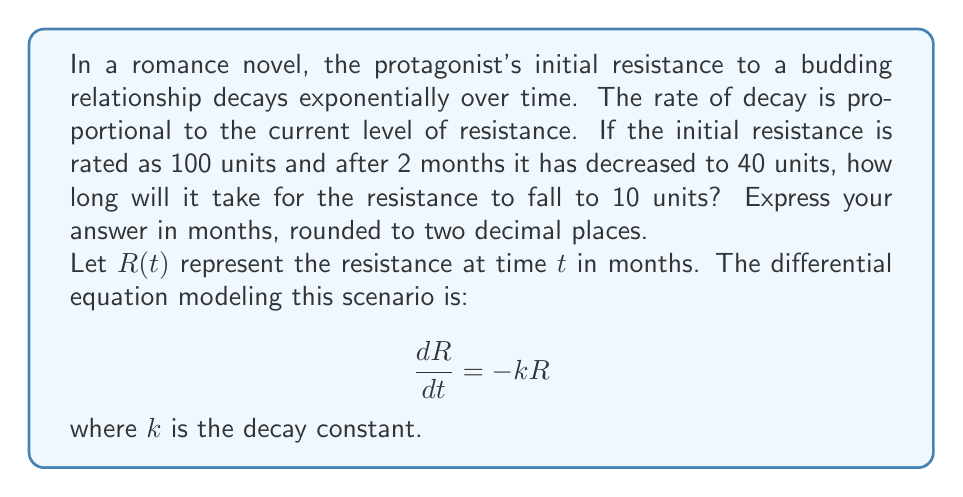Show me your answer to this math problem. To solve this problem, we'll follow these steps:

1) First, we need to find the value of $k$ using the given information.
   The general solution to the differential equation is:
   
   $$R(t) = R_0e^{-kt}$$
   
   where $R_0$ is the initial resistance.

2) We know that $R_0 = 100$ and $R(2) = 40$. Let's substitute these values:

   $$40 = 100e^{-2k}$$

3) Solving for $k$:
   
   $$\frac{40}{100} = e^{-2k}$$
   $$0.4 = e^{-2k}$$
   $$\ln(0.4) = -2k$$
   $$k = -\frac{\ln(0.4)}{2} \approx 0.4576$$

4) Now that we have $k$, we can use the general solution to find when $R(t) = 10$:

   $$10 = 100e^{-0.4576t}$$

5) Solving for $t$:
   
   $$0.1 = e^{-0.4576t}$$
   $$\ln(0.1) = -0.4576t$$
   $$t = -\frac{\ln(0.1)}{0.4576} \approx 5.0175$$

6) Rounding to two decimal places, we get 5.02 months.
Answer: 5.02 months 